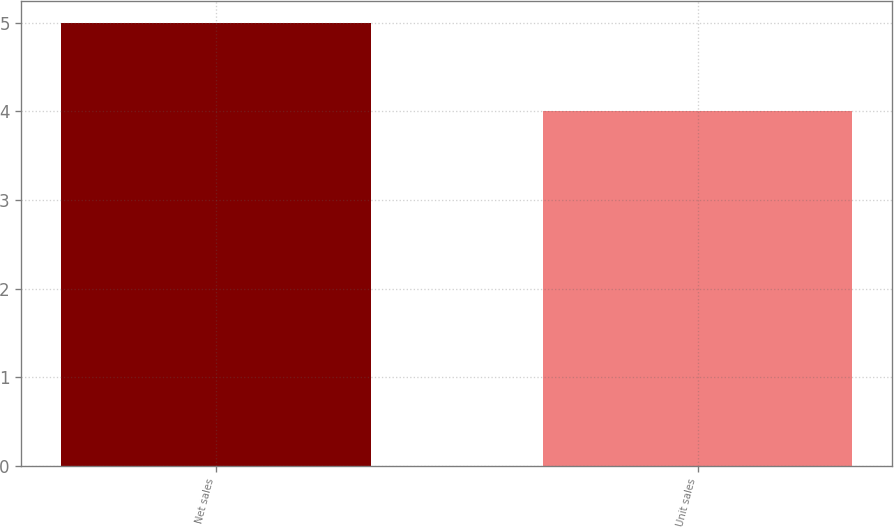<chart> <loc_0><loc_0><loc_500><loc_500><bar_chart><fcel>Net sales<fcel>Unit sales<nl><fcel>5<fcel>4<nl></chart> 